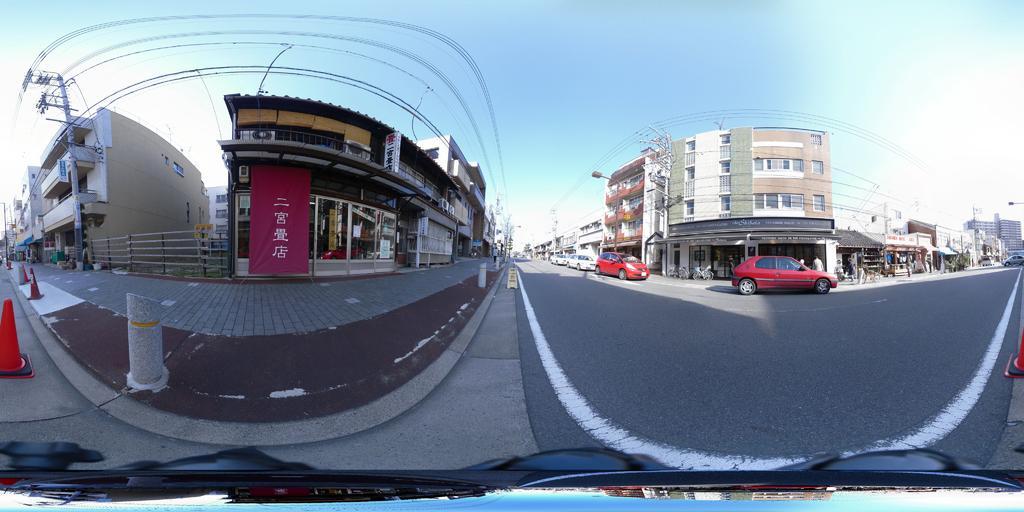Describe this image in one or two sentences. In this image, we can see few buildings, walkway, poles, traffic cones, banners. Vehicles on the road. Background there is a sky. At the bottom, we can see some object. 